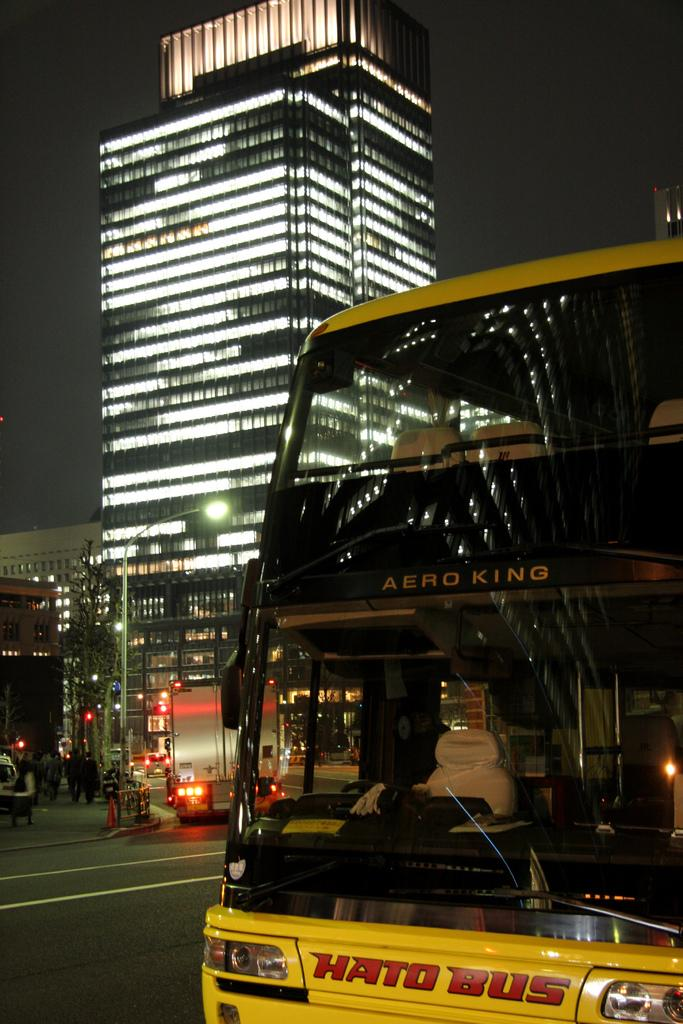<image>
Provide a brief description of the given image. Yellow bus with the word Hato Bus on it on the street. 